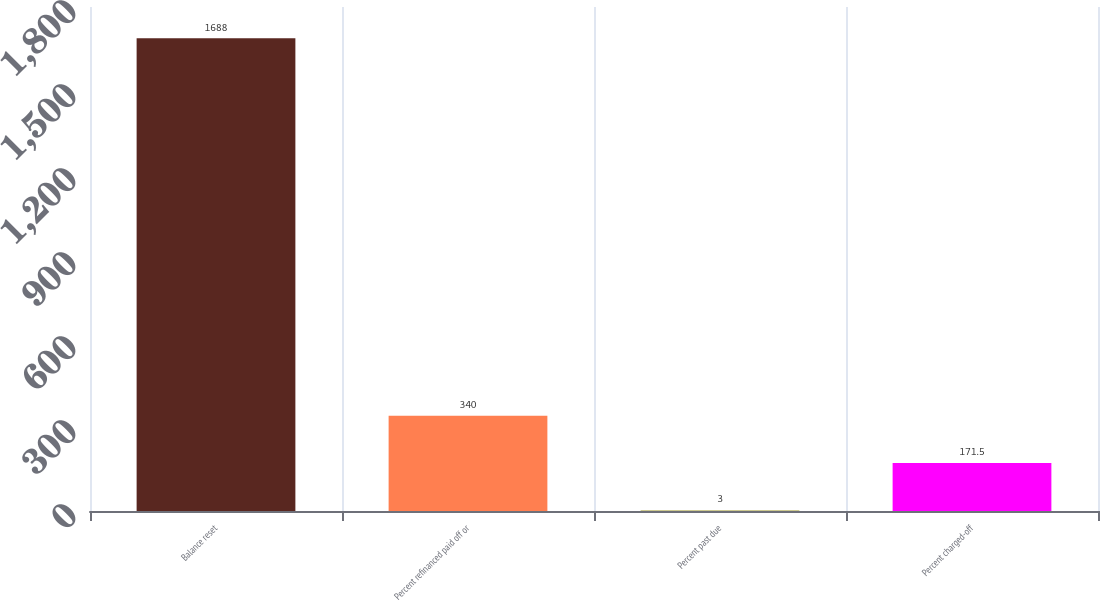<chart> <loc_0><loc_0><loc_500><loc_500><bar_chart><fcel>Balance reset<fcel>Percent refinanced paid off or<fcel>Percent past due<fcel>Percent charged-off<nl><fcel>1688<fcel>340<fcel>3<fcel>171.5<nl></chart> 